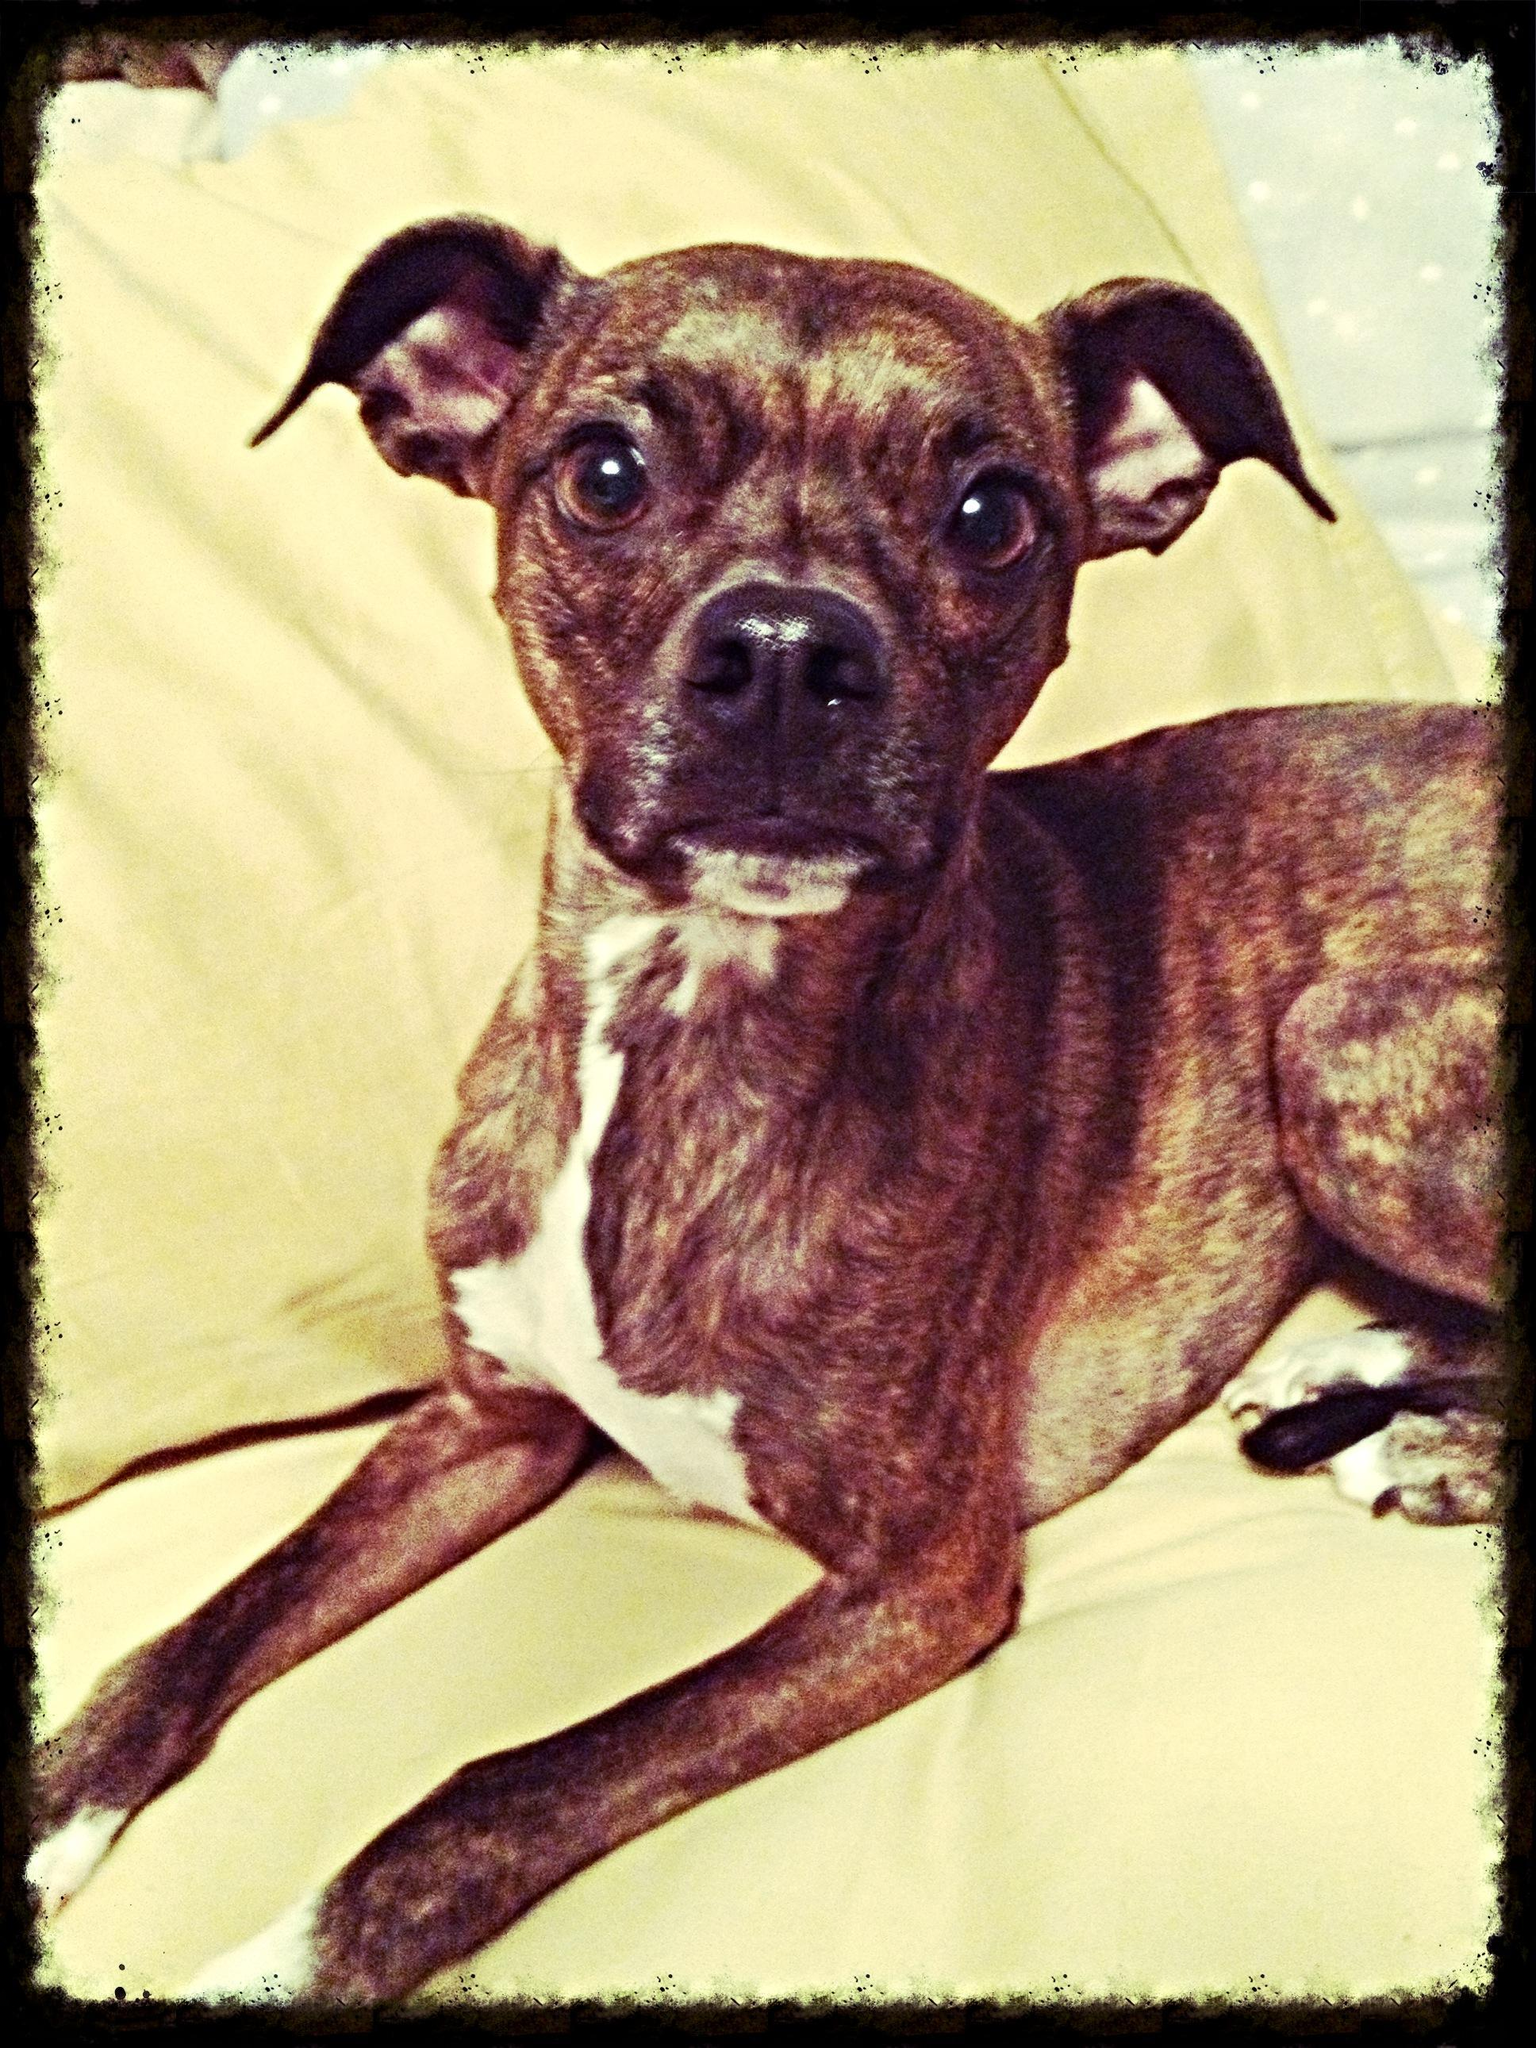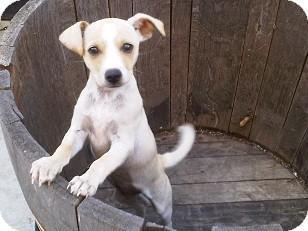The first image is the image on the left, the second image is the image on the right. Considering the images on both sides, is "The dog in the image on the right is sitting in the grass outside." valid? Answer yes or no. No. The first image is the image on the left, the second image is the image on the right. Assess this claim about the two images: "The dog on the left wears a collar and stands on all fours, and the dog on the right is in a grassy spot and has black-and-white coloring.". Correct or not? Answer yes or no. No. 